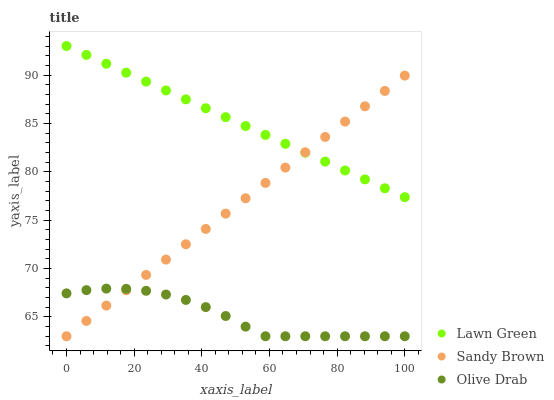Does Olive Drab have the minimum area under the curve?
Answer yes or no. Yes. Does Lawn Green have the maximum area under the curve?
Answer yes or no. Yes. Does Sandy Brown have the minimum area under the curve?
Answer yes or no. No. Does Sandy Brown have the maximum area under the curve?
Answer yes or no. No. Is Lawn Green the smoothest?
Answer yes or no. Yes. Is Olive Drab the roughest?
Answer yes or no. Yes. Is Sandy Brown the smoothest?
Answer yes or no. No. Is Sandy Brown the roughest?
Answer yes or no. No. Does Sandy Brown have the lowest value?
Answer yes or no. Yes. Does Lawn Green have the highest value?
Answer yes or no. Yes. Does Sandy Brown have the highest value?
Answer yes or no. No. Is Olive Drab less than Lawn Green?
Answer yes or no. Yes. Is Lawn Green greater than Olive Drab?
Answer yes or no. Yes. Does Sandy Brown intersect Olive Drab?
Answer yes or no. Yes. Is Sandy Brown less than Olive Drab?
Answer yes or no. No. Is Sandy Brown greater than Olive Drab?
Answer yes or no. No. Does Olive Drab intersect Lawn Green?
Answer yes or no. No. 